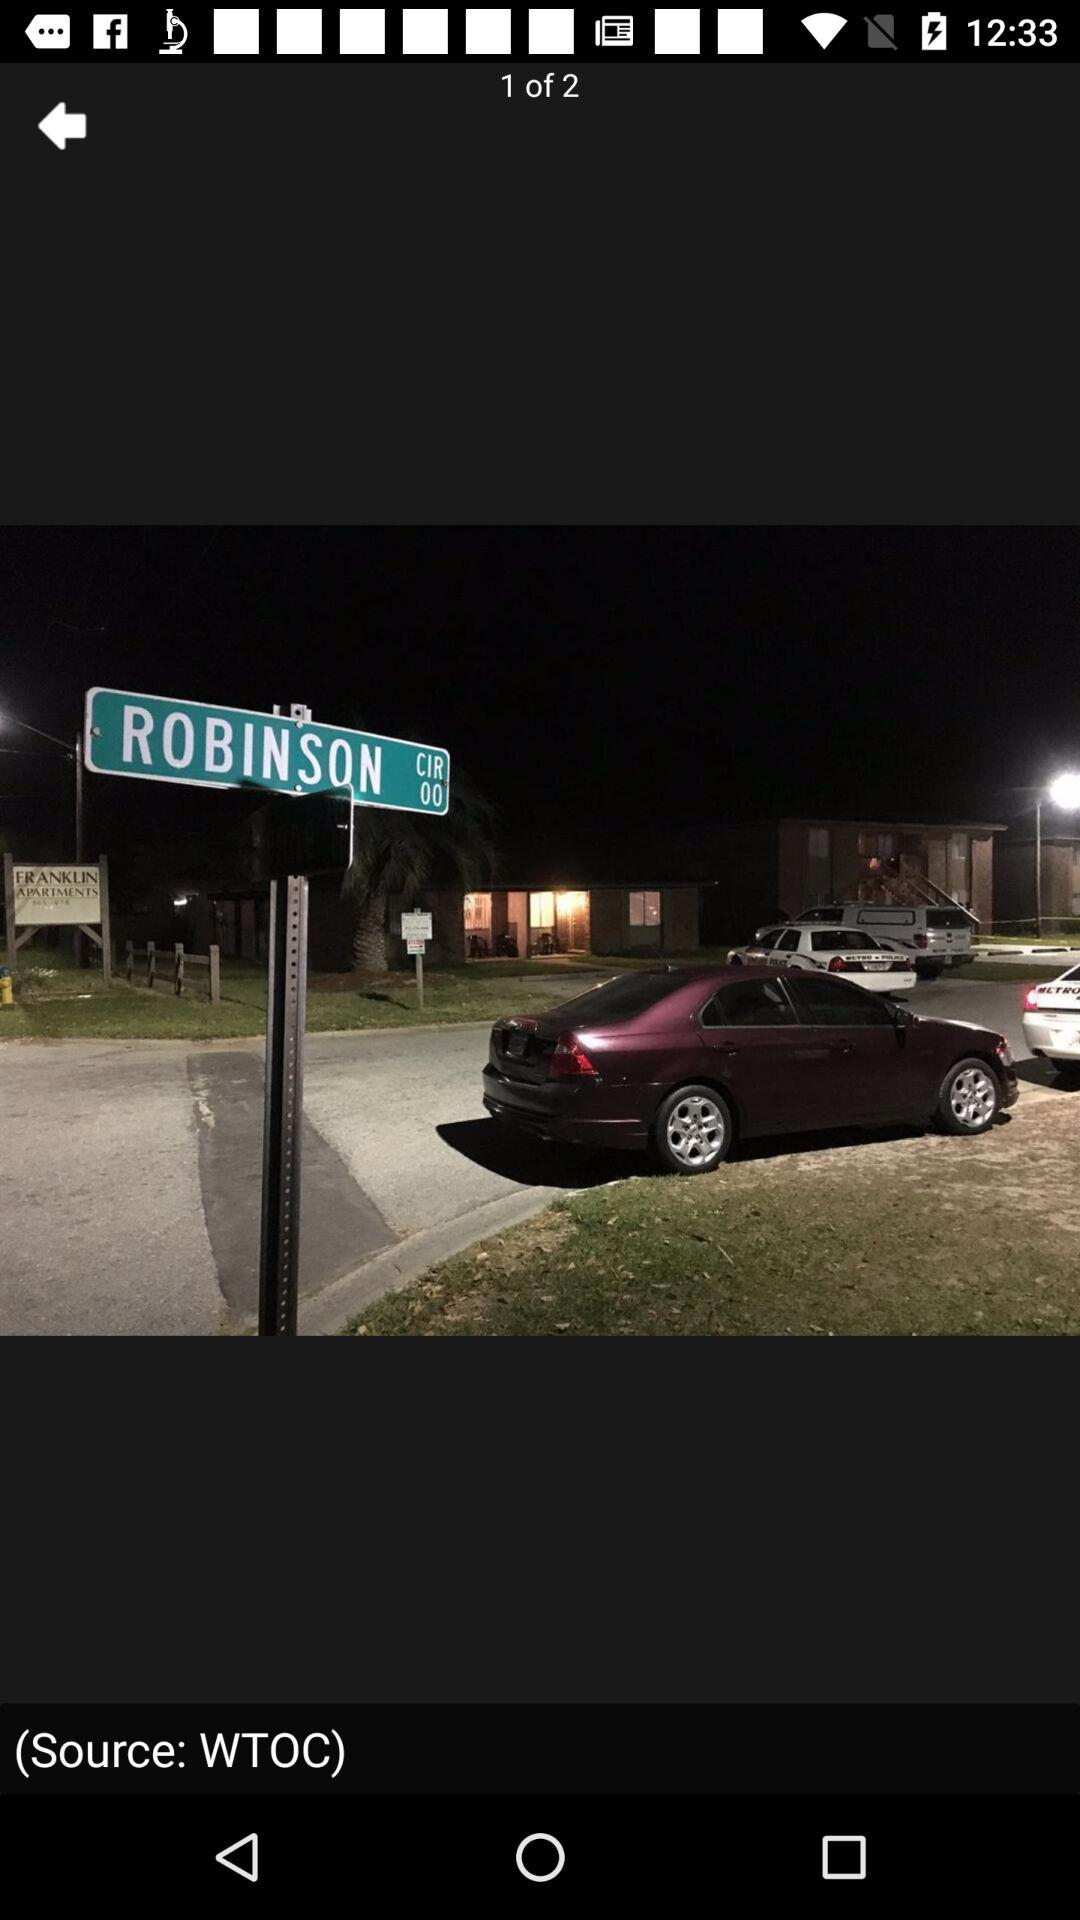How many images in total are there? There are 2 images. 